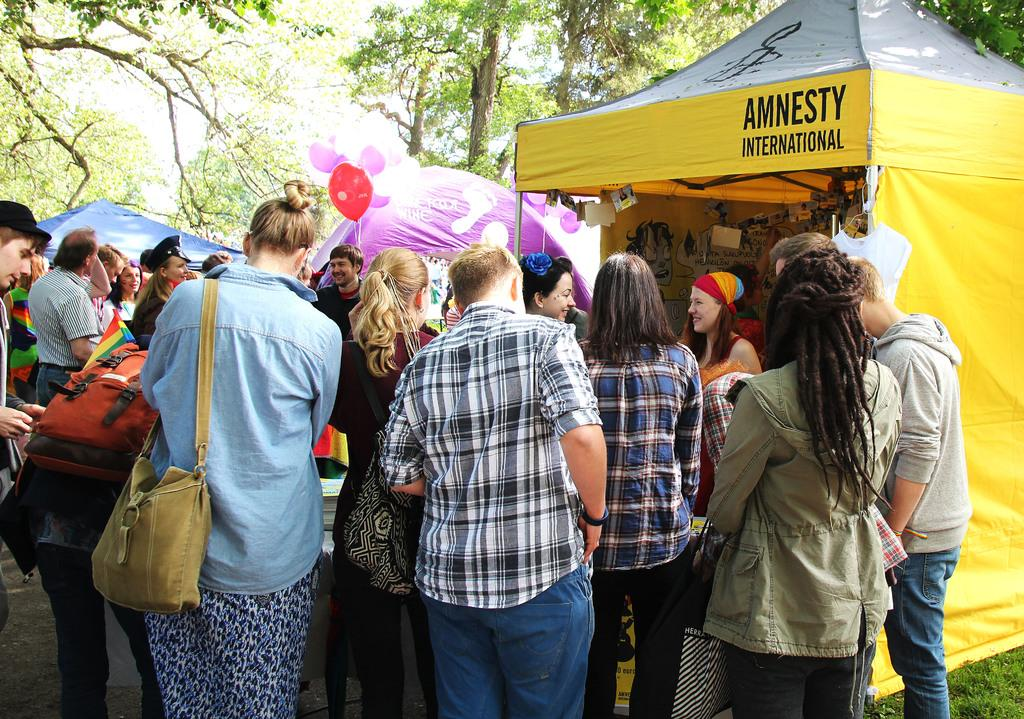What type of event is depicted in the image? The image appears to depict an Expo. Can you describe the people in the image? There is a crowd outside the stalls in the image. How many stalls are visible in the image? There are three stalls in the image. What can be seen in the background of the image? There are trees and the sky visible in the background of the image. What type of paper is being used by the crook in the scene? There is no crook or paper present in the image; it depicts an Expo with a crowd and stalls. 